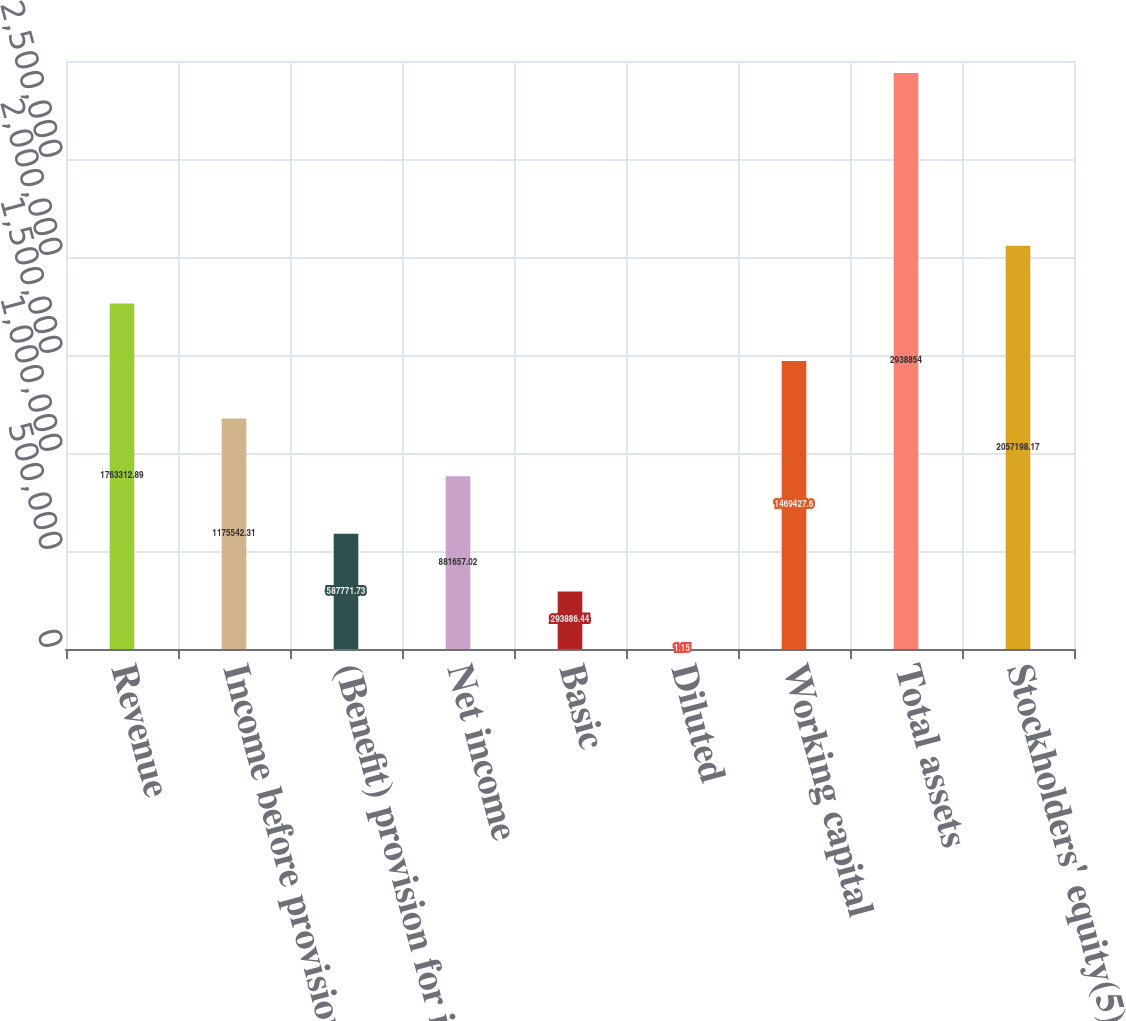Convert chart. <chart><loc_0><loc_0><loc_500><loc_500><bar_chart><fcel>Revenue<fcel>Income before provisions for<fcel>(Benefit) provision for income<fcel>Net income<fcel>Basic<fcel>Diluted<fcel>Working capital<fcel>Total assets<fcel>Stockholders' equity(5)<nl><fcel>1.76331e+06<fcel>1.17554e+06<fcel>587772<fcel>881657<fcel>293886<fcel>1.15<fcel>1.46943e+06<fcel>2.93885e+06<fcel>2.0572e+06<nl></chart> 